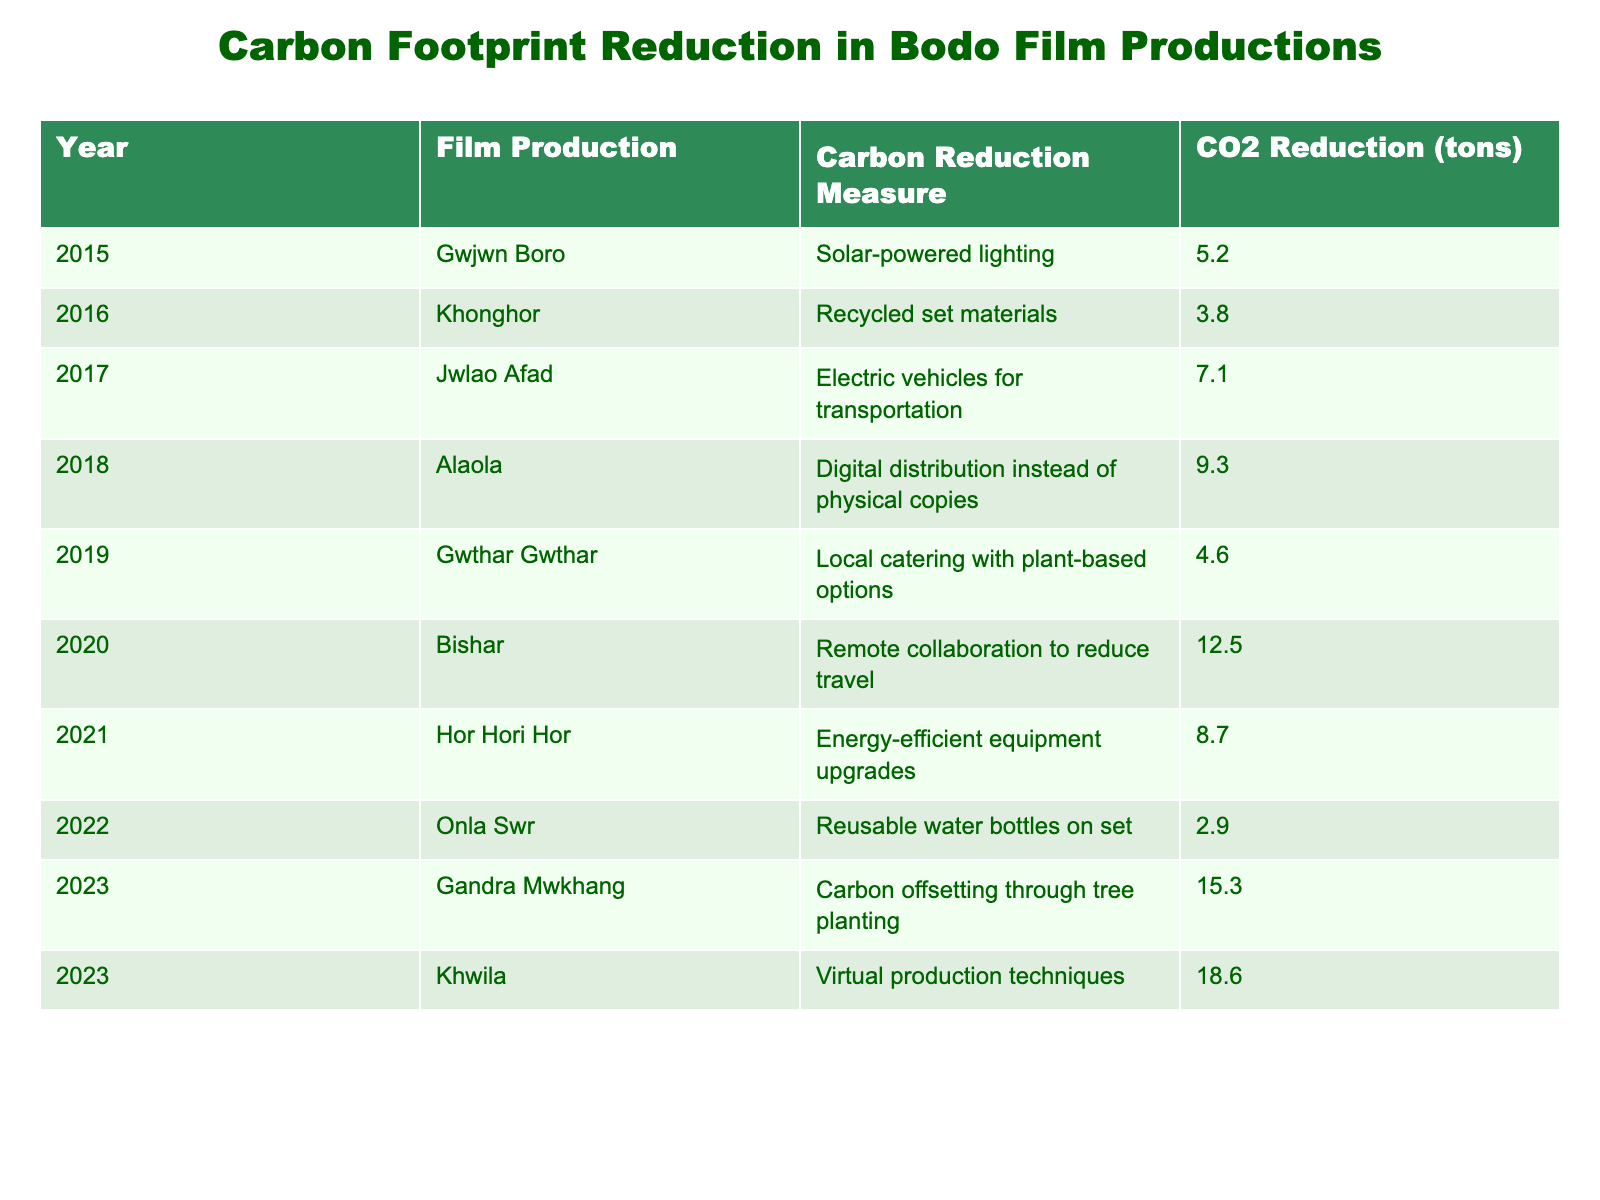What is the CO2 reduction achieved by the film Gandra Mwkhang? The table lists the CO2 reduction measure for each film. For Gandra Mwkhang, the CO2 reduction achieved is 15.3 tons as indicated in the respective row.
Answer: 15.3 tons Which year saw the highest CO2 reduction and how much was it? By examining the CO2 reduction values for each year, we see that the highest reduction is 18.6 tons in 2023 for the film Khwila.
Answer: 2023, 18.6 tons What is the total CO2 reduction across all Bodo film productions listed from 2015 to 2023? To find the total CO2 reduction, I sum up all the values in the CO2 reduction column: 5.2 + 3.8 + 7.1 + 9.3 + 4.6 + 12.5 + 8.7 + 2.9 + 15.3 + 18.6 = 88.0 tons.
Answer: 88.0 tons Did any film production in 2020 achieve a CO2 reduction over 10 tons? The table provides the CO2 reduction for the film Bishar in 2020, which is 12.5 tons. Since this is over 10 tons, the answer is yes.
Answer: Yes What is the average CO2 reduction achieved per year from 2015 to 2023? To calculate the average, first find the total CO2 reduction (88.0 tons) and divide it by the number of years (9 years). Thus, the average is 88.0 / 9 ≈ 9.78 tons.
Answer: ~9.78 tons How many films utilized solar-powered lighting as a carbon reduction measure? Referring to the table, only one film, Gwjwn Boro from 2015, used solar-powered lighting. Therefore, the answer is one.
Answer: 1 Which years had carbon reduction measures focused on transportation? By analyzing the table, the films Jwlao Afad (2017) and Bishar (2020) implemented carbon reduction measures related to transportation (electric vehicles and remote collaboration to reduce travel respectively).
Answer: 2017 and 2020 What was the difference in CO2 reduction between the films Gwjwn Boro and Khonghor? The CO2 reduction for Gwjwn Boro is 5.2 tons and for Khonghor is 3.8 tons. The difference is 5.2 - 3.8 = 1.4 tons.
Answer: 1.4 tons Are there more films with plant-based options or with remote collaboration measures? The table shows one film (Gwthar Gwthar, 2019) that used local catering with plant-based options, and one film (Bishar, 2020) that used remote collaboration. They are equal in number.
Answer: They are equal (1 each) Which production year had the lowest CO2 reduction and what was the measure used? By scanning the table, I see that the lowest CO2 reduction was 2.9 tons for Onla Swr in 2022, which used reusable water bottles on set.
Answer: 2022, reusable water bottles on set 